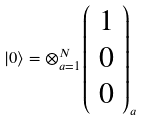<formula> <loc_0><loc_0><loc_500><loc_500>\left | 0 \right \rangle = \otimes _ { a = 1 } ^ { N } \left ( \begin{array} { c } 1 \\ 0 \\ 0 \end{array} \right ) _ { a }</formula> 